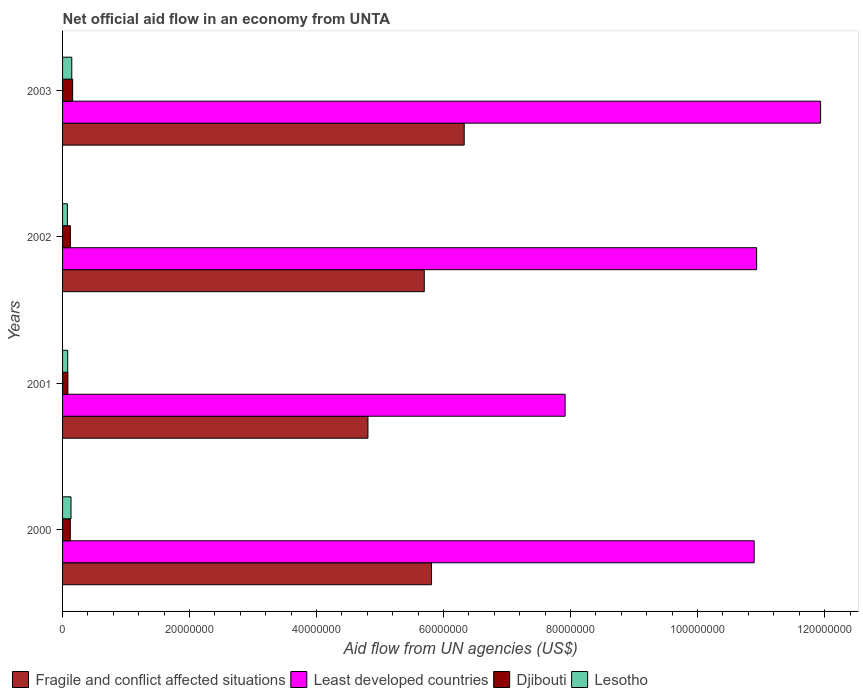How many different coloured bars are there?
Offer a very short reply. 4. How many groups of bars are there?
Make the answer very short. 4. Are the number of bars per tick equal to the number of legend labels?
Provide a short and direct response. Yes. How many bars are there on the 2nd tick from the top?
Your answer should be very brief. 4. How many bars are there on the 3rd tick from the bottom?
Ensure brevity in your answer.  4. What is the label of the 4th group of bars from the top?
Your answer should be compact. 2000. What is the net official aid flow in Lesotho in 2003?
Provide a succinct answer. 1.45e+06. Across all years, what is the maximum net official aid flow in Least developed countries?
Keep it short and to the point. 1.19e+08. Across all years, what is the minimum net official aid flow in Least developed countries?
Your answer should be compact. 7.91e+07. In which year was the net official aid flow in Least developed countries minimum?
Your answer should be very brief. 2001. What is the total net official aid flow in Lesotho in the graph?
Your answer should be compact. 4.35e+06. What is the difference between the net official aid flow in Fragile and conflict affected situations in 2000 and that in 2001?
Keep it short and to the point. 1.00e+07. What is the difference between the net official aid flow in Djibouti in 2003 and the net official aid flow in Fragile and conflict affected situations in 2002?
Give a very brief answer. -5.54e+07. What is the average net official aid flow in Least developed countries per year?
Offer a terse response. 1.04e+08. In the year 2000, what is the difference between the net official aid flow in Fragile and conflict affected situations and net official aid flow in Lesotho?
Make the answer very short. 5.68e+07. What is the ratio of the net official aid flow in Lesotho in 2001 to that in 2002?
Keep it short and to the point. 1.07. Is the net official aid flow in Lesotho in 2000 less than that in 2002?
Ensure brevity in your answer.  No. Is the difference between the net official aid flow in Fragile and conflict affected situations in 2002 and 2003 greater than the difference between the net official aid flow in Lesotho in 2002 and 2003?
Offer a very short reply. No. What is the difference between the highest and the lowest net official aid flow in Fragile and conflict affected situations?
Ensure brevity in your answer.  1.52e+07. In how many years, is the net official aid flow in Fragile and conflict affected situations greater than the average net official aid flow in Fragile and conflict affected situations taken over all years?
Make the answer very short. 3. Is the sum of the net official aid flow in Least developed countries in 2001 and 2003 greater than the maximum net official aid flow in Djibouti across all years?
Offer a very short reply. Yes. Is it the case that in every year, the sum of the net official aid flow in Fragile and conflict affected situations and net official aid flow in Lesotho is greater than the sum of net official aid flow in Djibouti and net official aid flow in Least developed countries?
Your answer should be very brief. Yes. What does the 4th bar from the top in 2001 represents?
Offer a very short reply. Fragile and conflict affected situations. What does the 2nd bar from the bottom in 2002 represents?
Make the answer very short. Least developed countries. How many bars are there?
Ensure brevity in your answer.  16. Are all the bars in the graph horizontal?
Provide a short and direct response. Yes. Are the values on the major ticks of X-axis written in scientific E-notation?
Provide a succinct answer. No. Does the graph contain grids?
Keep it short and to the point. No. How are the legend labels stacked?
Your response must be concise. Horizontal. What is the title of the graph?
Your answer should be very brief. Net official aid flow in an economy from UNTA. Does "Albania" appear as one of the legend labels in the graph?
Keep it short and to the point. No. What is the label or title of the X-axis?
Provide a succinct answer. Aid flow from UN agencies (US$). What is the Aid flow from UN agencies (US$) in Fragile and conflict affected situations in 2000?
Your answer should be compact. 5.81e+07. What is the Aid flow from UN agencies (US$) in Least developed countries in 2000?
Provide a short and direct response. 1.09e+08. What is the Aid flow from UN agencies (US$) of Djibouti in 2000?
Your answer should be compact. 1.22e+06. What is the Aid flow from UN agencies (US$) in Lesotho in 2000?
Offer a terse response. 1.33e+06. What is the Aid flow from UN agencies (US$) of Fragile and conflict affected situations in 2001?
Your answer should be compact. 4.81e+07. What is the Aid flow from UN agencies (US$) of Least developed countries in 2001?
Offer a very short reply. 7.91e+07. What is the Aid flow from UN agencies (US$) of Djibouti in 2001?
Offer a very short reply. 8.40e+05. What is the Aid flow from UN agencies (US$) of Lesotho in 2001?
Your answer should be compact. 8.10e+05. What is the Aid flow from UN agencies (US$) in Fragile and conflict affected situations in 2002?
Provide a succinct answer. 5.70e+07. What is the Aid flow from UN agencies (US$) in Least developed countries in 2002?
Offer a terse response. 1.09e+08. What is the Aid flow from UN agencies (US$) in Djibouti in 2002?
Make the answer very short. 1.23e+06. What is the Aid flow from UN agencies (US$) of Lesotho in 2002?
Make the answer very short. 7.60e+05. What is the Aid flow from UN agencies (US$) of Fragile and conflict affected situations in 2003?
Your response must be concise. 6.32e+07. What is the Aid flow from UN agencies (US$) in Least developed countries in 2003?
Offer a very short reply. 1.19e+08. What is the Aid flow from UN agencies (US$) of Djibouti in 2003?
Provide a short and direct response. 1.59e+06. What is the Aid flow from UN agencies (US$) of Lesotho in 2003?
Provide a short and direct response. 1.45e+06. Across all years, what is the maximum Aid flow from UN agencies (US$) in Fragile and conflict affected situations?
Ensure brevity in your answer.  6.32e+07. Across all years, what is the maximum Aid flow from UN agencies (US$) of Least developed countries?
Keep it short and to the point. 1.19e+08. Across all years, what is the maximum Aid flow from UN agencies (US$) in Djibouti?
Your answer should be very brief. 1.59e+06. Across all years, what is the maximum Aid flow from UN agencies (US$) in Lesotho?
Provide a short and direct response. 1.45e+06. Across all years, what is the minimum Aid flow from UN agencies (US$) of Fragile and conflict affected situations?
Offer a terse response. 4.81e+07. Across all years, what is the minimum Aid flow from UN agencies (US$) of Least developed countries?
Provide a succinct answer. 7.91e+07. Across all years, what is the minimum Aid flow from UN agencies (US$) of Djibouti?
Your response must be concise. 8.40e+05. Across all years, what is the minimum Aid flow from UN agencies (US$) of Lesotho?
Provide a short and direct response. 7.60e+05. What is the total Aid flow from UN agencies (US$) in Fragile and conflict affected situations in the graph?
Your answer should be very brief. 2.26e+08. What is the total Aid flow from UN agencies (US$) in Least developed countries in the graph?
Keep it short and to the point. 4.17e+08. What is the total Aid flow from UN agencies (US$) of Djibouti in the graph?
Offer a terse response. 4.88e+06. What is the total Aid flow from UN agencies (US$) of Lesotho in the graph?
Keep it short and to the point. 4.35e+06. What is the difference between the Aid flow from UN agencies (US$) in Fragile and conflict affected situations in 2000 and that in 2001?
Your answer should be very brief. 1.00e+07. What is the difference between the Aid flow from UN agencies (US$) in Least developed countries in 2000 and that in 2001?
Provide a succinct answer. 2.98e+07. What is the difference between the Aid flow from UN agencies (US$) in Djibouti in 2000 and that in 2001?
Provide a short and direct response. 3.80e+05. What is the difference between the Aid flow from UN agencies (US$) of Lesotho in 2000 and that in 2001?
Keep it short and to the point. 5.20e+05. What is the difference between the Aid flow from UN agencies (US$) in Fragile and conflict affected situations in 2000 and that in 2002?
Offer a very short reply. 1.14e+06. What is the difference between the Aid flow from UN agencies (US$) of Least developed countries in 2000 and that in 2002?
Ensure brevity in your answer.  -3.90e+05. What is the difference between the Aid flow from UN agencies (US$) in Djibouti in 2000 and that in 2002?
Your answer should be very brief. -10000. What is the difference between the Aid flow from UN agencies (US$) of Lesotho in 2000 and that in 2002?
Provide a succinct answer. 5.70e+05. What is the difference between the Aid flow from UN agencies (US$) in Fragile and conflict affected situations in 2000 and that in 2003?
Your response must be concise. -5.15e+06. What is the difference between the Aid flow from UN agencies (US$) of Least developed countries in 2000 and that in 2003?
Ensure brevity in your answer.  -1.05e+07. What is the difference between the Aid flow from UN agencies (US$) in Djibouti in 2000 and that in 2003?
Your response must be concise. -3.70e+05. What is the difference between the Aid flow from UN agencies (US$) of Lesotho in 2000 and that in 2003?
Provide a short and direct response. -1.20e+05. What is the difference between the Aid flow from UN agencies (US$) of Fragile and conflict affected situations in 2001 and that in 2002?
Offer a very short reply. -8.87e+06. What is the difference between the Aid flow from UN agencies (US$) in Least developed countries in 2001 and that in 2002?
Ensure brevity in your answer.  -3.02e+07. What is the difference between the Aid flow from UN agencies (US$) of Djibouti in 2001 and that in 2002?
Provide a succinct answer. -3.90e+05. What is the difference between the Aid flow from UN agencies (US$) of Lesotho in 2001 and that in 2002?
Provide a succinct answer. 5.00e+04. What is the difference between the Aid flow from UN agencies (US$) of Fragile and conflict affected situations in 2001 and that in 2003?
Ensure brevity in your answer.  -1.52e+07. What is the difference between the Aid flow from UN agencies (US$) of Least developed countries in 2001 and that in 2003?
Give a very brief answer. -4.02e+07. What is the difference between the Aid flow from UN agencies (US$) of Djibouti in 2001 and that in 2003?
Make the answer very short. -7.50e+05. What is the difference between the Aid flow from UN agencies (US$) of Lesotho in 2001 and that in 2003?
Your answer should be very brief. -6.40e+05. What is the difference between the Aid flow from UN agencies (US$) of Fragile and conflict affected situations in 2002 and that in 2003?
Offer a terse response. -6.29e+06. What is the difference between the Aid flow from UN agencies (US$) in Least developed countries in 2002 and that in 2003?
Provide a succinct answer. -1.01e+07. What is the difference between the Aid flow from UN agencies (US$) in Djibouti in 2002 and that in 2003?
Provide a succinct answer. -3.60e+05. What is the difference between the Aid flow from UN agencies (US$) in Lesotho in 2002 and that in 2003?
Offer a terse response. -6.90e+05. What is the difference between the Aid flow from UN agencies (US$) in Fragile and conflict affected situations in 2000 and the Aid flow from UN agencies (US$) in Least developed countries in 2001?
Offer a terse response. -2.10e+07. What is the difference between the Aid flow from UN agencies (US$) of Fragile and conflict affected situations in 2000 and the Aid flow from UN agencies (US$) of Djibouti in 2001?
Offer a terse response. 5.73e+07. What is the difference between the Aid flow from UN agencies (US$) in Fragile and conflict affected situations in 2000 and the Aid flow from UN agencies (US$) in Lesotho in 2001?
Offer a very short reply. 5.73e+07. What is the difference between the Aid flow from UN agencies (US$) in Least developed countries in 2000 and the Aid flow from UN agencies (US$) in Djibouti in 2001?
Offer a terse response. 1.08e+08. What is the difference between the Aid flow from UN agencies (US$) in Least developed countries in 2000 and the Aid flow from UN agencies (US$) in Lesotho in 2001?
Give a very brief answer. 1.08e+08. What is the difference between the Aid flow from UN agencies (US$) of Fragile and conflict affected situations in 2000 and the Aid flow from UN agencies (US$) of Least developed countries in 2002?
Your answer should be compact. -5.12e+07. What is the difference between the Aid flow from UN agencies (US$) in Fragile and conflict affected situations in 2000 and the Aid flow from UN agencies (US$) in Djibouti in 2002?
Provide a succinct answer. 5.69e+07. What is the difference between the Aid flow from UN agencies (US$) of Fragile and conflict affected situations in 2000 and the Aid flow from UN agencies (US$) of Lesotho in 2002?
Your answer should be compact. 5.73e+07. What is the difference between the Aid flow from UN agencies (US$) of Least developed countries in 2000 and the Aid flow from UN agencies (US$) of Djibouti in 2002?
Your response must be concise. 1.08e+08. What is the difference between the Aid flow from UN agencies (US$) of Least developed countries in 2000 and the Aid flow from UN agencies (US$) of Lesotho in 2002?
Ensure brevity in your answer.  1.08e+08. What is the difference between the Aid flow from UN agencies (US$) in Djibouti in 2000 and the Aid flow from UN agencies (US$) in Lesotho in 2002?
Give a very brief answer. 4.60e+05. What is the difference between the Aid flow from UN agencies (US$) in Fragile and conflict affected situations in 2000 and the Aid flow from UN agencies (US$) in Least developed countries in 2003?
Provide a short and direct response. -6.13e+07. What is the difference between the Aid flow from UN agencies (US$) in Fragile and conflict affected situations in 2000 and the Aid flow from UN agencies (US$) in Djibouti in 2003?
Keep it short and to the point. 5.65e+07. What is the difference between the Aid flow from UN agencies (US$) in Fragile and conflict affected situations in 2000 and the Aid flow from UN agencies (US$) in Lesotho in 2003?
Make the answer very short. 5.66e+07. What is the difference between the Aid flow from UN agencies (US$) in Least developed countries in 2000 and the Aid flow from UN agencies (US$) in Djibouti in 2003?
Ensure brevity in your answer.  1.07e+08. What is the difference between the Aid flow from UN agencies (US$) of Least developed countries in 2000 and the Aid flow from UN agencies (US$) of Lesotho in 2003?
Offer a very short reply. 1.07e+08. What is the difference between the Aid flow from UN agencies (US$) in Djibouti in 2000 and the Aid flow from UN agencies (US$) in Lesotho in 2003?
Make the answer very short. -2.30e+05. What is the difference between the Aid flow from UN agencies (US$) of Fragile and conflict affected situations in 2001 and the Aid flow from UN agencies (US$) of Least developed countries in 2002?
Your answer should be compact. -6.12e+07. What is the difference between the Aid flow from UN agencies (US$) of Fragile and conflict affected situations in 2001 and the Aid flow from UN agencies (US$) of Djibouti in 2002?
Your answer should be very brief. 4.69e+07. What is the difference between the Aid flow from UN agencies (US$) in Fragile and conflict affected situations in 2001 and the Aid flow from UN agencies (US$) in Lesotho in 2002?
Offer a very short reply. 4.73e+07. What is the difference between the Aid flow from UN agencies (US$) of Least developed countries in 2001 and the Aid flow from UN agencies (US$) of Djibouti in 2002?
Provide a succinct answer. 7.79e+07. What is the difference between the Aid flow from UN agencies (US$) of Least developed countries in 2001 and the Aid flow from UN agencies (US$) of Lesotho in 2002?
Offer a terse response. 7.84e+07. What is the difference between the Aid flow from UN agencies (US$) of Fragile and conflict affected situations in 2001 and the Aid flow from UN agencies (US$) of Least developed countries in 2003?
Ensure brevity in your answer.  -7.13e+07. What is the difference between the Aid flow from UN agencies (US$) in Fragile and conflict affected situations in 2001 and the Aid flow from UN agencies (US$) in Djibouti in 2003?
Provide a short and direct response. 4.65e+07. What is the difference between the Aid flow from UN agencies (US$) in Fragile and conflict affected situations in 2001 and the Aid flow from UN agencies (US$) in Lesotho in 2003?
Your response must be concise. 4.66e+07. What is the difference between the Aid flow from UN agencies (US$) of Least developed countries in 2001 and the Aid flow from UN agencies (US$) of Djibouti in 2003?
Your response must be concise. 7.76e+07. What is the difference between the Aid flow from UN agencies (US$) of Least developed countries in 2001 and the Aid flow from UN agencies (US$) of Lesotho in 2003?
Give a very brief answer. 7.77e+07. What is the difference between the Aid flow from UN agencies (US$) in Djibouti in 2001 and the Aid flow from UN agencies (US$) in Lesotho in 2003?
Your answer should be compact. -6.10e+05. What is the difference between the Aid flow from UN agencies (US$) of Fragile and conflict affected situations in 2002 and the Aid flow from UN agencies (US$) of Least developed countries in 2003?
Provide a succinct answer. -6.24e+07. What is the difference between the Aid flow from UN agencies (US$) of Fragile and conflict affected situations in 2002 and the Aid flow from UN agencies (US$) of Djibouti in 2003?
Your answer should be very brief. 5.54e+07. What is the difference between the Aid flow from UN agencies (US$) in Fragile and conflict affected situations in 2002 and the Aid flow from UN agencies (US$) in Lesotho in 2003?
Offer a very short reply. 5.55e+07. What is the difference between the Aid flow from UN agencies (US$) of Least developed countries in 2002 and the Aid flow from UN agencies (US$) of Djibouti in 2003?
Make the answer very short. 1.08e+08. What is the difference between the Aid flow from UN agencies (US$) of Least developed countries in 2002 and the Aid flow from UN agencies (US$) of Lesotho in 2003?
Offer a terse response. 1.08e+08. What is the average Aid flow from UN agencies (US$) of Fragile and conflict affected situations per year?
Offer a terse response. 5.66e+07. What is the average Aid flow from UN agencies (US$) in Least developed countries per year?
Ensure brevity in your answer.  1.04e+08. What is the average Aid flow from UN agencies (US$) in Djibouti per year?
Your answer should be very brief. 1.22e+06. What is the average Aid flow from UN agencies (US$) of Lesotho per year?
Give a very brief answer. 1.09e+06. In the year 2000, what is the difference between the Aid flow from UN agencies (US$) of Fragile and conflict affected situations and Aid flow from UN agencies (US$) of Least developed countries?
Provide a succinct answer. -5.08e+07. In the year 2000, what is the difference between the Aid flow from UN agencies (US$) in Fragile and conflict affected situations and Aid flow from UN agencies (US$) in Djibouti?
Your answer should be compact. 5.69e+07. In the year 2000, what is the difference between the Aid flow from UN agencies (US$) in Fragile and conflict affected situations and Aid flow from UN agencies (US$) in Lesotho?
Provide a succinct answer. 5.68e+07. In the year 2000, what is the difference between the Aid flow from UN agencies (US$) in Least developed countries and Aid flow from UN agencies (US$) in Djibouti?
Make the answer very short. 1.08e+08. In the year 2000, what is the difference between the Aid flow from UN agencies (US$) of Least developed countries and Aid flow from UN agencies (US$) of Lesotho?
Offer a terse response. 1.08e+08. In the year 2000, what is the difference between the Aid flow from UN agencies (US$) of Djibouti and Aid flow from UN agencies (US$) of Lesotho?
Offer a very short reply. -1.10e+05. In the year 2001, what is the difference between the Aid flow from UN agencies (US$) of Fragile and conflict affected situations and Aid flow from UN agencies (US$) of Least developed countries?
Keep it short and to the point. -3.10e+07. In the year 2001, what is the difference between the Aid flow from UN agencies (US$) of Fragile and conflict affected situations and Aid flow from UN agencies (US$) of Djibouti?
Offer a terse response. 4.72e+07. In the year 2001, what is the difference between the Aid flow from UN agencies (US$) of Fragile and conflict affected situations and Aid flow from UN agencies (US$) of Lesotho?
Your answer should be very brief. 4.73e+07. In the year 2001, what is the difference between the Aid flow from UN agencies (US$) in Least developed countries and Aid flow from UN agencies (US$) in Djibouti?
Provide a short and direct response. 7.83e+07. In the year 2001, what is the difference between the Aid flow from UN agencies (US$) in Least developed countries and Aid flow from UN agencies (US$) in Lesotho?
Your answer should be compact. 7.83e+07. In the year 2002, what is the difference between the Aid flow from UN agencies (US$) of Fragile and conflict affected situations and Aid flow from UN agencies (US$) of Least developed countries?
Your response must be concise. -5.23e+07. In the year 2002, what is the difference between the Aid flow from UN agencies (US$) of Fragile and conflict affected situations and Aid flow from UN agencies (US$) of Djibouti?
Offer a very short reply. 5.57e+07. In the year 2002, what is the difference between the Aid flow from UN agencies (US$) in Fragile and conflict affected situations and Aid flow from UN agencies (US$) in Lesotho?
Make the answer very short. 5.62e+07. In the year 2002, what is the difference between the Aid flow from UN agencies (US$) of Least developed countries and Aid flow from UN agencies (US$) of Djibouti?
Your response must be concise. 1.08e+08. In the year 2002, what is the difference between the Aid flow from UN agencies (US$) of Least developed countries and Aid flow from UN agencies (US$) of Lesotho?
Offer a terse response. 1.09e+08. In the year 2002, what is the difference between the Aid flow from UN agencies (US$) in Djibouti and Aid flow from UN agencies (US$) in Lesotho?
Offer a terse response. 4.70e+05. In the year 2003, what is the difference between the Aid flow from UN agencies (US$) in Fragile and conflict affected situations and Aid flow from UN agencies (US$) in Least developed countries?
Ensure brevity in your answer.  -5.61e+07. In the year 2003, what is the difference between the Aid flow from UN agencies (US$) in Fragile and conflict affected situations and Aid flow from UN agencies (US$) in Djibouti?
Make the answer very short. 6.17e+07. In the year 2003, what is the difference between the Aid flow from UN agencies (US$) of Fragile and conflict affected situations and Aid flow from UN agencies (US$) of Lesotho?
Make the answer very short. 6.18e+07. In the year 2003, what is the difference between the Aid flow from UN agencies (US$) of Least developed countries and Aid flow from UN agencies (US$) of Djibouti?
Provide a short and direct response. 1.18e+08. In the year 2003, what is the difference between the Aid flow from UN agencies (US$) of Least developed countries and Aid flow from UN agencies (US$) of Lesotho?
Provide a short and direct response. 1.18e+08. What is the ratio of the Aid flow from UN agencies (US$) of Fragile and conflict affected situations in 2000 to that in 2001?
Your answer should be compact. 1.21. What is the ratio of the Aid flow from UN agencies (US$) in Least developed countries in 2000 to that in 2001?
Provide a short and direct response. 1.38. What is the ratio of the Aid flow from UN agencies (US$) of Djibouti in 2000 to that in 2001?
Offer a very short reply. 1.45. What is the ratio of the Aid flow from UN agencies (US$) in Lesotho in 2000 to that in 2001?
Keep it short and to the point. 1.64. What is the ratio of the Aid flow from UN agencies (US$) in Fragile and conflict affected situations in 2000 to that in 2002?
Your answer should be compact. 1.02. What is the ratio of the Aid flow from UN agencies (US$) in Least developed countries in 2000 to that in 2002?
Offer a very short reply. 1. What is the ratio of the Aid flow from UN agencies (US$) in Djibouti in 2000 to that in 2002?
Ensure brevity in your answer.  0.99. What is the ratio of the Aid flow from UN agencies (US$) in Fragile and conflict affected situations in 2000 to that in 2003?
Offer a terse response. 0.92. What is the ratio of the Aid flow from UN agencies (US$) in Least developed countries in 2000 to that in 2003?
Make the answer very short. 0.91. What is the ratio of the Aid flow from UN agencies (US$) in Djibouti in 2000 to that in 2003?
Ensure brevity in your answer.  0.77. What is the ratio of the Aid flow from UN agencies (US$) of Lesotho in 2000 to that in 2003?
Your answer should be compact. 0.92. What is the ratio of the Aid flow from UN agencies (US$) of Fragile and conflict affected situations in 2001 to that in 2002?
Offer a terse response. 0.84. What is the ratio of the Aid flow from UN agencies (US$) of Least developed countries in 2001 to that in 2002?
Give a very brief answer. 0.72. What is the ratio of the Aid flow from UN agencies (US$) in Djibouti in 2001 to that in 2002?
Keep it short and to the point. 0.68. What is the ratio of the Aid flow from UN agencies (US$) in Lesotho in 2001 to that in 2002?
Keep it short and to the point. 1.07. What is the ratio of the Aid flow from UN agencies (US$) in Fragile and conflict affected situations in 2001 to that in 2003?
Your response must be concise. 0.76. What is the ratio of the Aid flow from UN agencies (US$) in Least developed countries in 2001 to that in 2003?
Ensure brevity in your answer.  0.66. What is the ratio of the Aid flow from UN agencies (US$) of Djibouti in 2001 to that in 2003?
Your response must be concise. 0.53. What is the ratio of the Aid flow from UN agencies (US$) of Lesotho in 2001 to that in 2003?
Your answer should be compact. 0.56. What is the ratio of the Aid flow from UN agencies (US$) of Fragile and conflict affected situations in 2002 to that in 2003?
Your response must be concise. 0.9. What is the ratio of the Aid flow from UN agencies (US$) in Least developed countries in 2002 to that in 2003?
Your response must be concise. 0.92. What is the ratio of the Aid flow from UN agencies (US$) in Djibouti in 2002 to that in 2003?
Give a very brief answer. 0.77. What is the ratio of the Aid flow from UN agencies (US$) in Lesotho in 2002 to that in 2003?
Provide a succinct answer. 0.52. What is the difference between the highest and the second highest Aid flow from UN agencies (US$) in Fragile and conflict affected situations?
Ensure brevity in your answer.  5.15e+06. What is the difference between the highest and the second highest Aid flow from UN agencies (US$) in Least developed countries?
Your answer should be very brief. 1.01e+07. What is the difference between the highest and the second highest Aid flow from UN agencies (US$) in Djibouti?
Your answer should be compact. 3.60e+05. What is the difference between the highest and the lowest Aid flow from UN agencies (US$) in Fragile and conflict affected situations?
Your answer should be compact. 1.52e+07. What is the difference between the highest and the lowest Aid flow from UN agencies (US$) in Least developed countries?
Give a very brief answer. 4.02e+07. What is the difference between the highest and the lowest Aid flow from UN agencies (US$) in Djibouti?
Make the answer very short. 7.50e+05. What is the difference between the highest and the lowest Aid flow from UN agencies (US$) in Lesotho?
Offer a very short reply. 6.90e+05. 